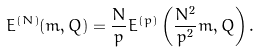<formula> <loc_0><loc_0><loc_500><loc_500>E ^ { ( N ) } ( m , Q ) = \frac { N } { p } E ^ { ( p ) } \left ( \frac { N ^ { 2 } } { p ^ { 2 } } m , Q \right ) .</formula> 